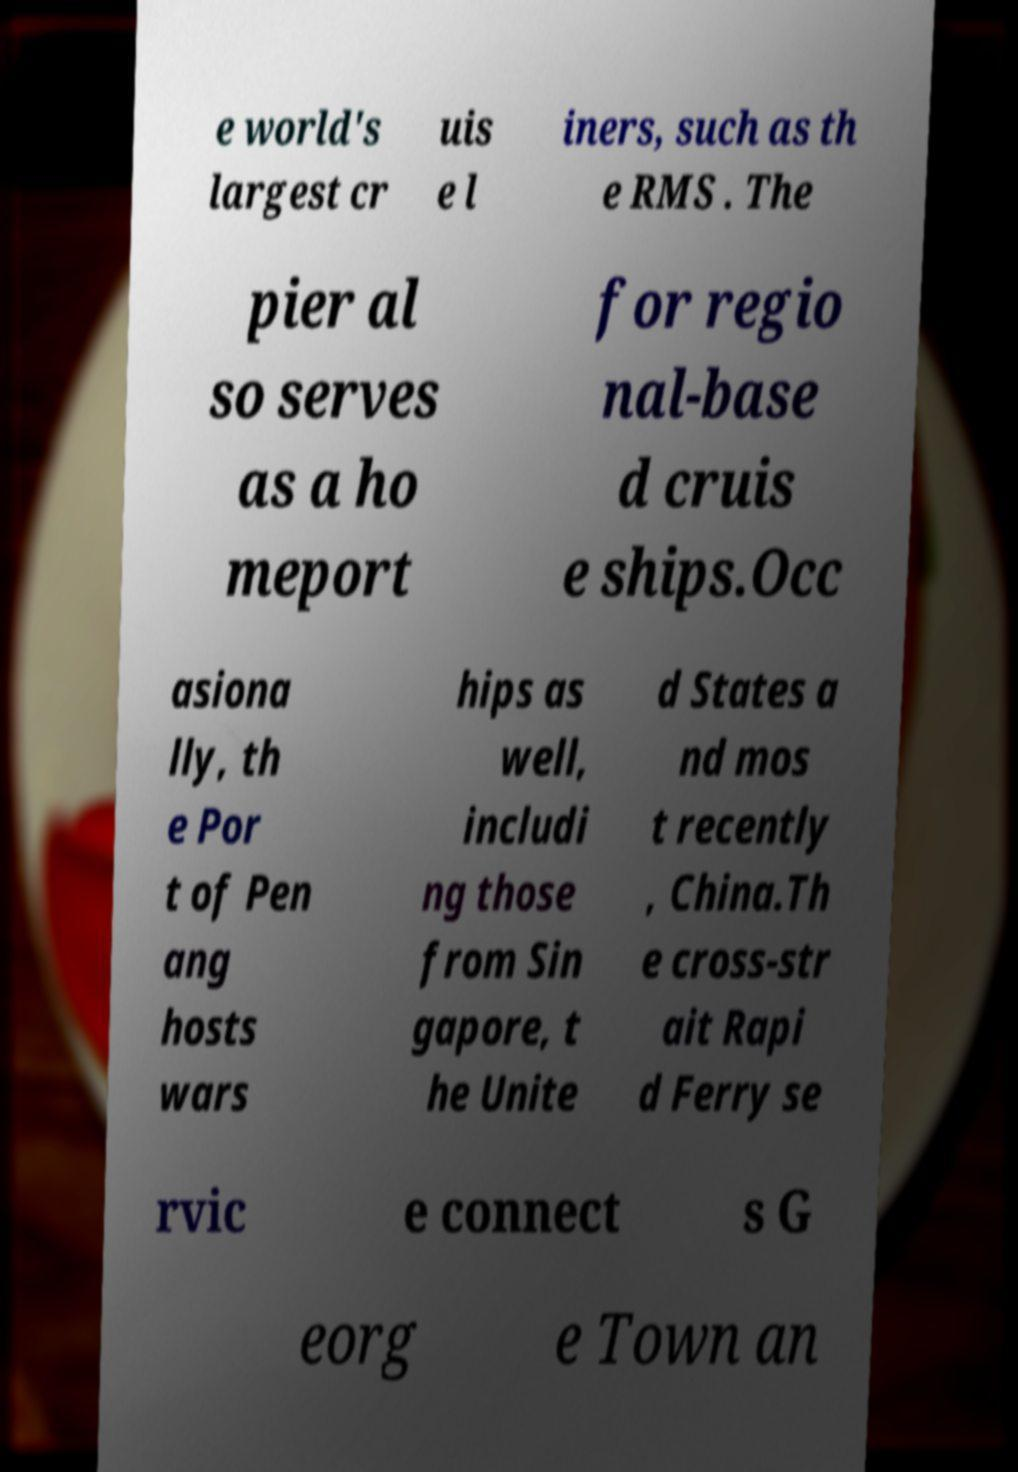I need the written content from this picture converted into text. Can you do that? e world's largest cr uis e l iners, such as th e RMS . The pier al so serves as a ho meport for regio nal-base d cruis e ships.Occ asiona lly, th e Por t of Pen ang hosts wars hips as well, includi ng those from Sin gapore, t he Unite d States a nd mos t recently , China.Th e cross-str ait Rapi d Ferry se rvic e connect s G eorg e Town an 